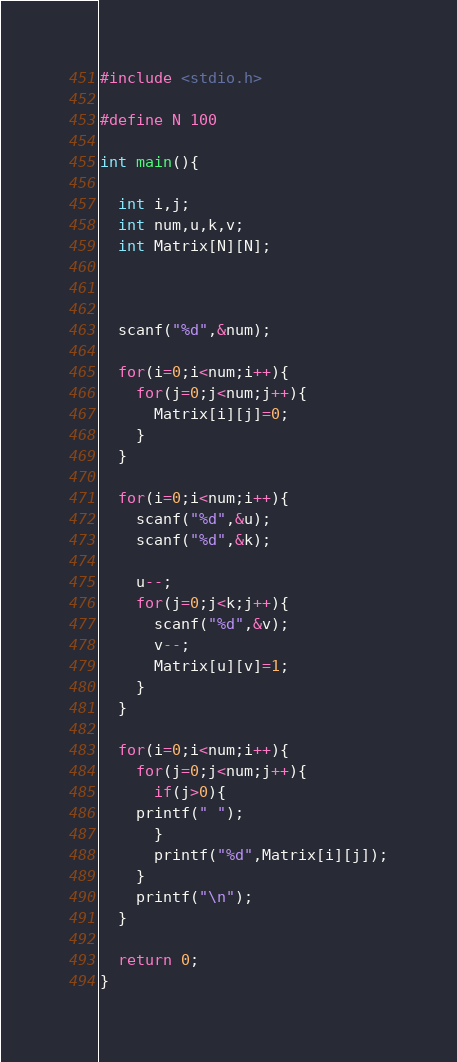Convert code to text. <code><loc_0><loc_0><loc_500><loc_500><_C_>#include <stdio.h>

#define N 100

int main(){

  int i,j;
  int num,u,k,v;
  int Matrix[N][N];

  

  scanf("%d",&num);

  for(i=0;i<num;i++){
    for(j=0;j<num;j++){
      Matrix[i][j]=0;
    }
  }

  for(i=0;i<num;i++){
    scanf("%d",&u);
    scanf("%d",&k);
  
    u--;
    for(j=0;j<k;j++){
      scanf("%d",&v);
      v--;
      Matrix[u][v]=1;
    }
  }

  for(i=0;i<num;i++){
    for(j=0;j<num;j++){
      if(j>0){
	printf(" ");
      }
      printf("%d",Matrix[i][j]);
    }
    printf("\n");
  }
  
  return 0;
}

</code> 